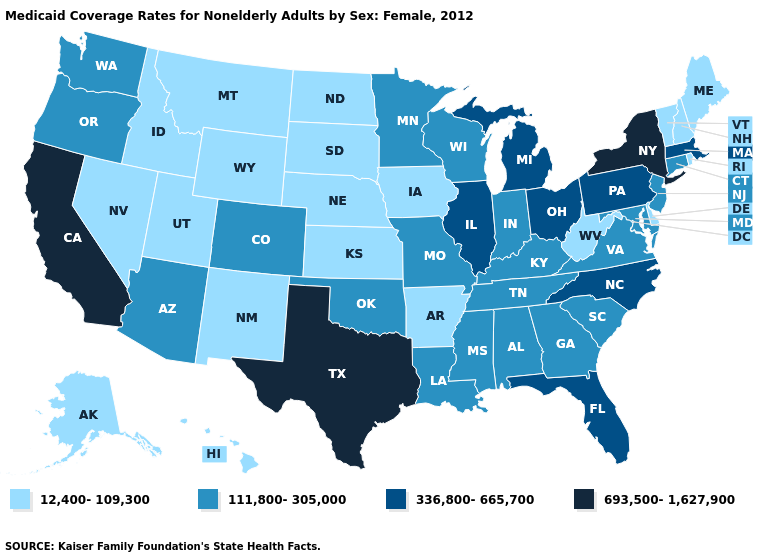What is the value of Mississippi?
Answer briefly. 111,800-305,000. Does the map have missing data?
Concise answer only. No. Does Wisconsin have a lower value than Virginia?
Answer briefly. No. Is the legend a continuous bar?
Answer briefly. No. Does Hawaii have the lowest value in the USA?
Write a very short answer. Yes. Does Idaho have the highest value in the West?
Give a very brief answer. No. Does New York have the highest value in the USA?
Quick response, please. Yes. Name the states that have a value in the range 12,400-109,300?
Quick response, please. Alaska, Arkansas, Delaware, Hawaii, Idaho, Iowa, Kansas, Maine, Montana, Nebraska, Nevada, New Hampshire, New Mexico, North Dakota, Rhode Island, South Dakota, Utah, Vermont, West Virginia, Wyoming. Among the states that border Pennsylvania , which have the highest value?
Answer briefly. New York. What is the value of Illinois?
Keep it brief. 336,800-665,700. Among the states that border Kentucky , does Illinois have the highest value?
Write a very short answer. Yes. What is the lowest value in states that border Louisiana?
Give a very brief answer. 12,400-109,300. What is the value of Minnesota?
Be succinct. 111,800-305,000. Does Oregon have a higher value than Maryland?
Give a very brief answer. No. 